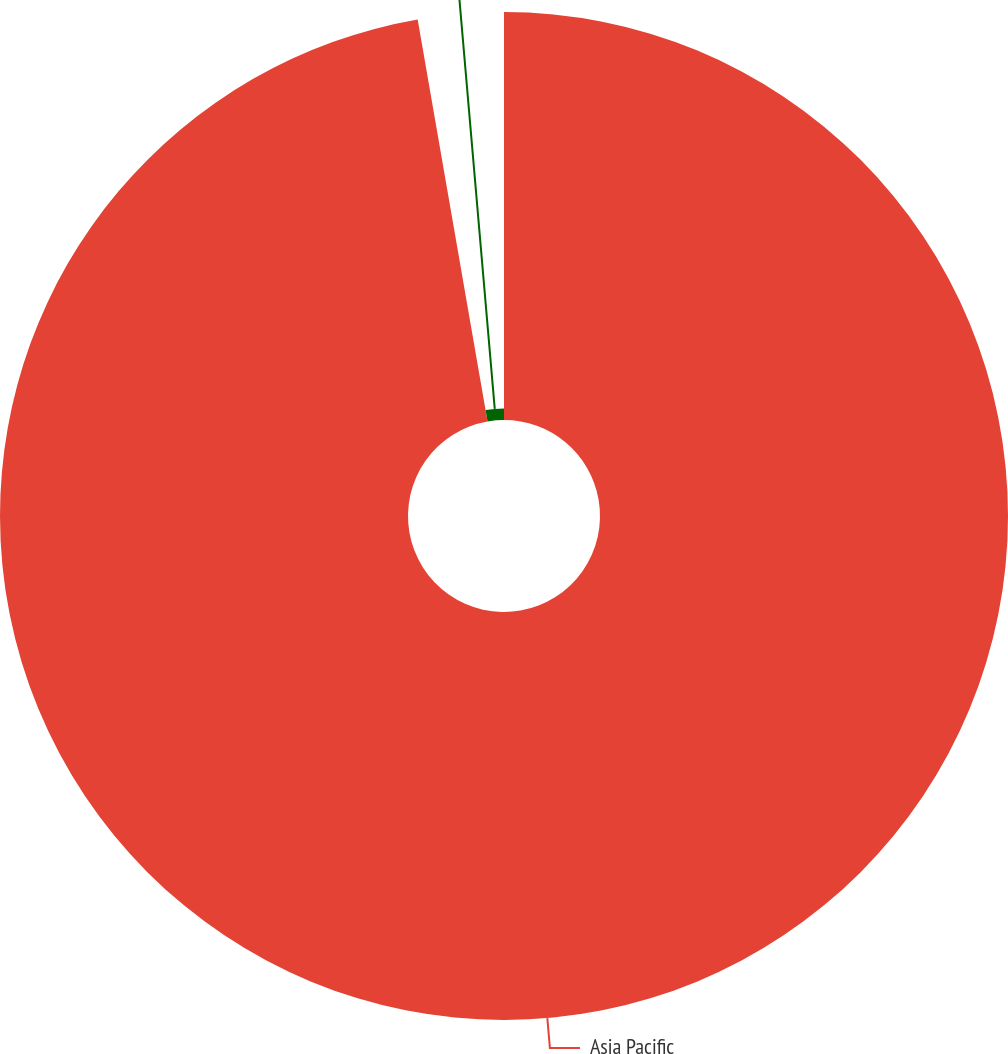Convert chart. <chart><loc_0><loc_0><loc_500><loc_500><pie_chart><fcel>Asia Pacific<fcel>Stock-based compensation<nl><fcel>97.26%<fcel>2.74%<nl></chart> 